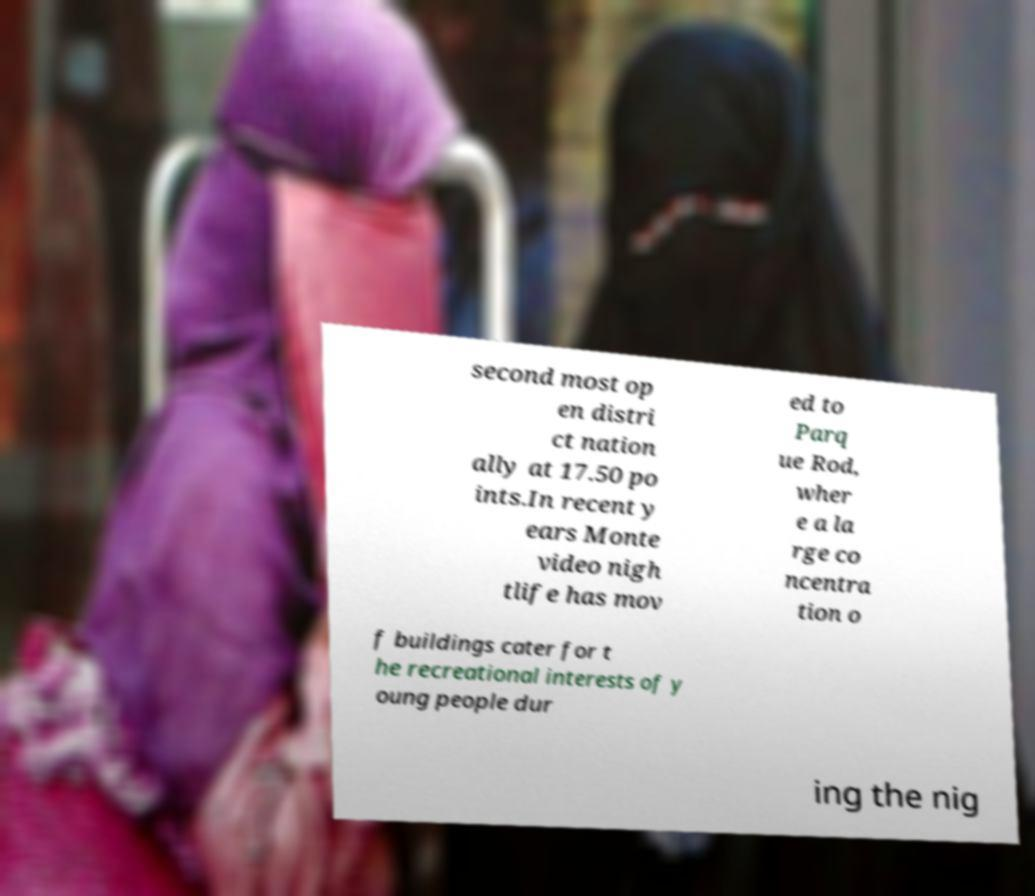Could you assist in decoding the text presented in this image and type it out clearly? second most op en distri ct nation ally at 17.50 po ints.In recent y ears Monte video nigh tlife has mov ed to Parq ue Rod, wher e a la rge co ncentra tion o f buildings cater for t he recreational interests of y oung people dur ing the nig 